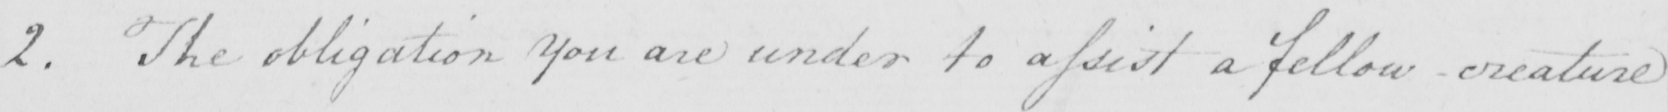What text is written in this handwritten line? 2 . The obligation you are under to assist a fellow creature 